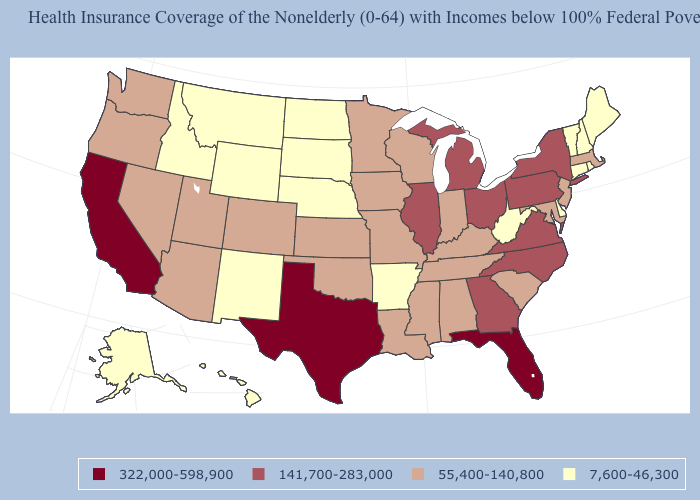Among the states that border Connecticut , does New York have the highest value?
Short answer required. Yes. Is the legend a continuous bar?
Answer briefly. No. What is the value of Montana?
Answer briefly. 7,600-46,300. Does Arizona have the lowest value in the West?
Be succinct. No. What is the lowest value in states that border North Carolina?
Give a very brief answer. 55,400-140,800. What is the value of Arizona?
Answer briefly. 55,400-140,800. What is the value of Nebraska?
Write a very short answer. 7,600-46,300. Does the first symbol in the legend represent the smallest category?
Be succinct. No. Name the states that have a value in the range 141,700-283,000?
Give a very brief answer. Georgia, Illinois, Michigan, New York, North Carolina, Ohio, Pennsylvania, Virginia. Name the states that have a value in the range 55,400-140,800?
Concise answer only. Alabama, Arizona, Colorado, Indiana, Iowa, Kansas, Kentucky, Louisiana, Maryland, Massachusetts, Minnesota, Mississippi, Missouri, Nevada, New Jersey, Oklahoma, Oregon, South Carolina, Tennessee, Utah, Washington, Wisconsin. What is the highest value in the USA?
Quick response, please. 322,000-598,900. Which states hav the highest value in the South?
Be succinct. Florida, Texas. What is the value of Hawaii?
Give a very brief answer. 7,600-46,300. What is the value of Michigan?
Keep it brief. 141,700-283,000. Does California have the highest value in the USA?
Short answer required. Yes. 